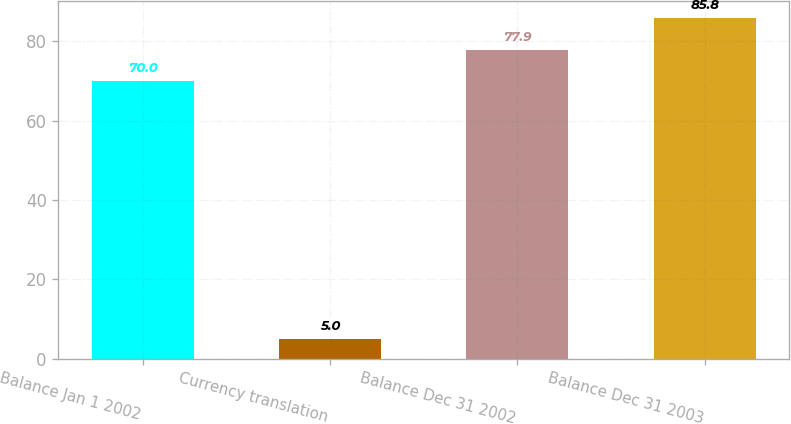Convert chart. <chart><loc_0><loc_0><loc_500><loc_500><bar_chart><fcel>Balance Jan 1 2002<fcel>Currency translation<fcel>Balance Dec 31 2002<fcel>Balance Dec 31 2003<nl><fcel>70<fcel>5<fcel>77.9<fcel>85.8<nl></chart> 